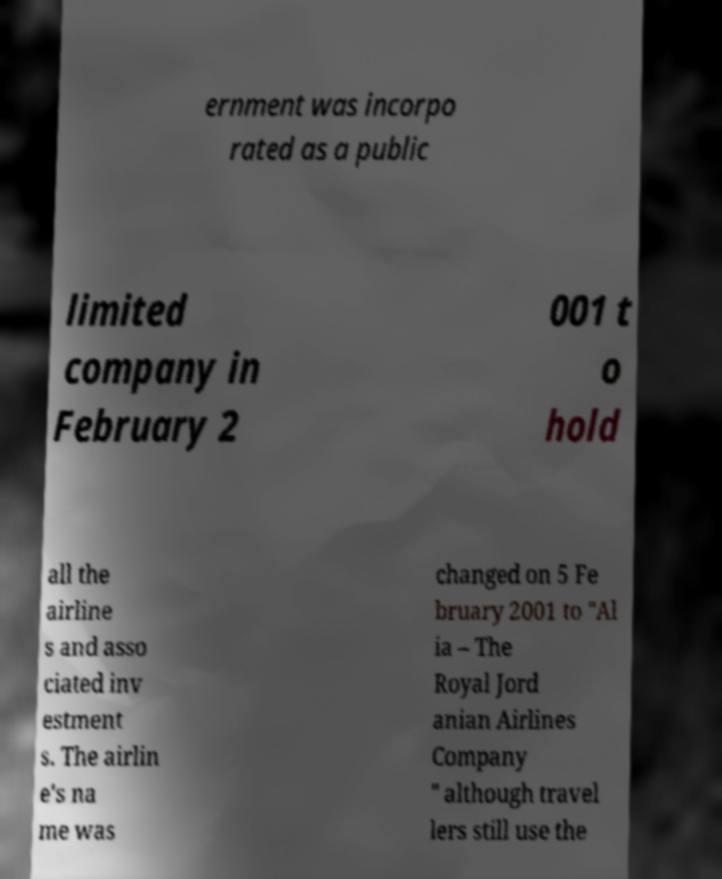Please read and relay the text visible in this image. What does it say? ernment was incorpo rated as a public limited company in February 2 001 t o hold all the airline s and asso ciated inv estment s. The airlin e's na me was changed on 5 Fe bruary 2001 to "Al ia – The Royal Jord anian Airlines Company " although travel lers still use the 